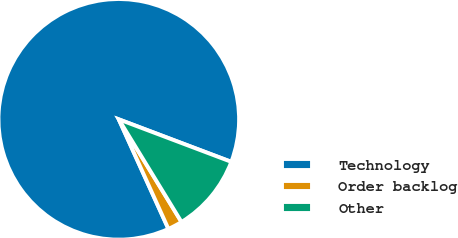Convert chart. <chart><loc_0><loc_0><loc_500><loc_500><pie_chart><fcel>Technology<fcel>Order backlog<fcel>Other<nl><fcel>87.52%<fcel>1.96%<fcel>10.52%<nl></chart> 